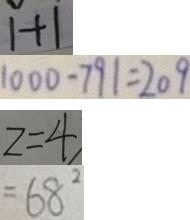Convert formula to latex. <formula><loc_0><loc_0><loc_500><loc_500>1 + 1 
 1 0 0 0 - 7 9 1 = 2 0 9 
 z = 4 
 = 6 8 ^ { 2 }</formula> 